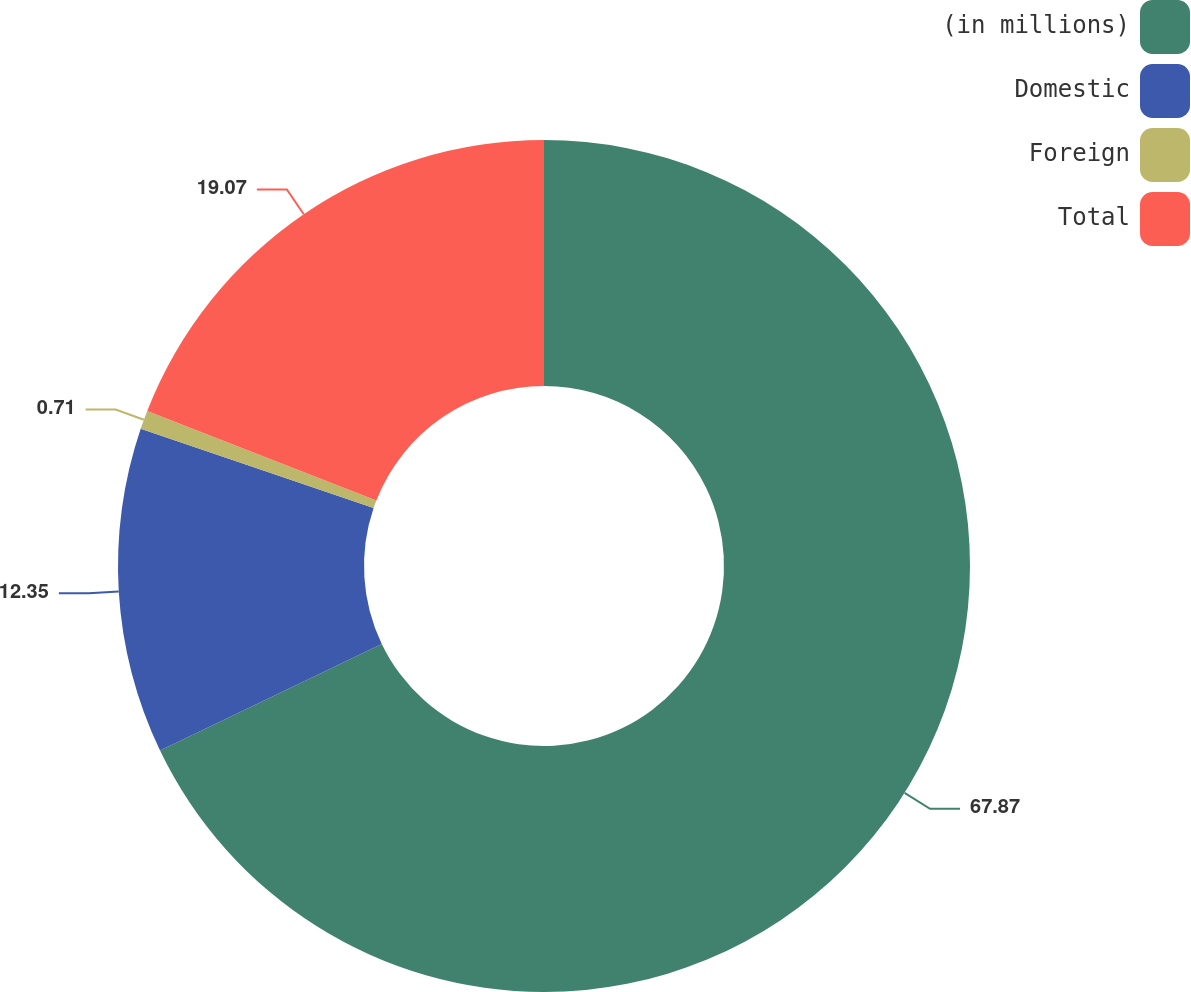<chart> <loc_0><loc_0><loc_500><loc_500><pie_chart><fcel>(in millions)<fcel>Domestic<fcel>Foreign<fcel>Total<nl><fcel>67.87%<fcel>12.35%<fcel>0.71%<fcel>19.07%<nl></chart> 